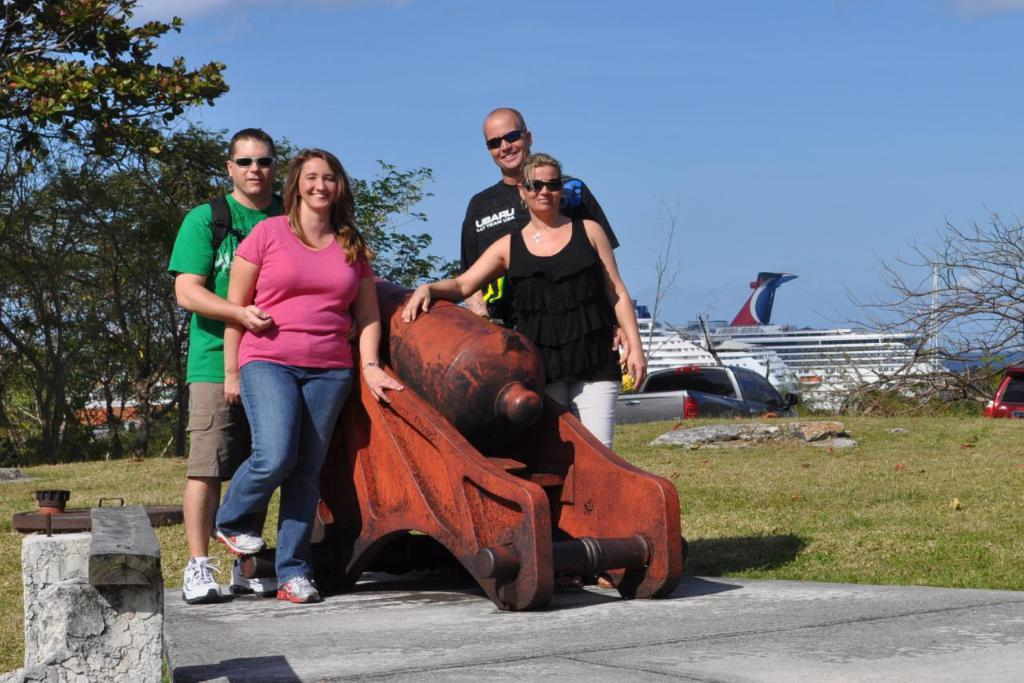What can be seen in the image involving people? There are people standing in the image. What other subjects are present in the image besides people? There are ships, trees, grass, and the sky visible in the image. How many robins can be seen playing with balls in the image? There are no robins or balls present in the image. What type of drop is visible in the image? There is no drop visible in the image. 